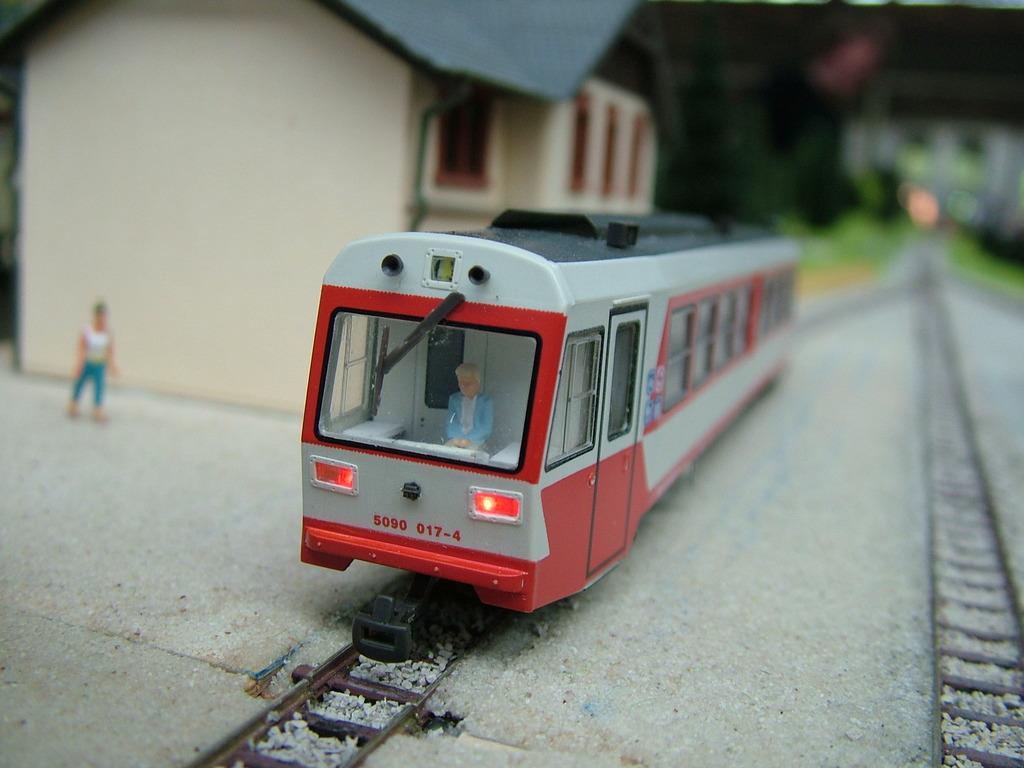Please provide a concise description of this image. In this image I can see there is a toy train, on the left side there is a house. 